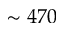<formula> <loc_0><loc_0><loc_500><loc_500>\sim 4 7 0</formula> 